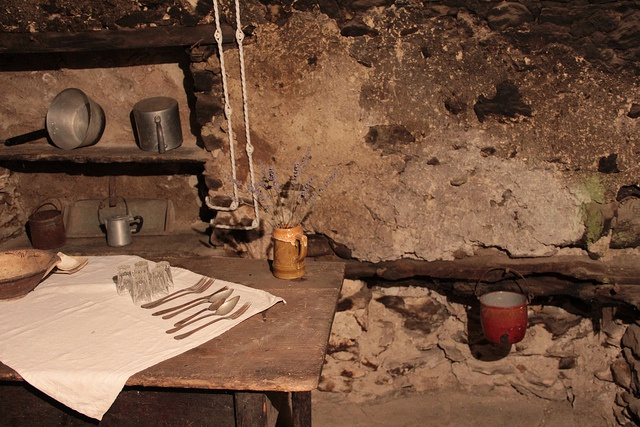Describe the objects in this image and their specific colors. I can see dining table in black, tan, and brown tones, potted plant in black, gray, brown, and tan tones, cup in black, maroon, and gray tones, bowl in black, brown, maroon, and tan tones, and cup in black, maroon, and gray tones in this image. 